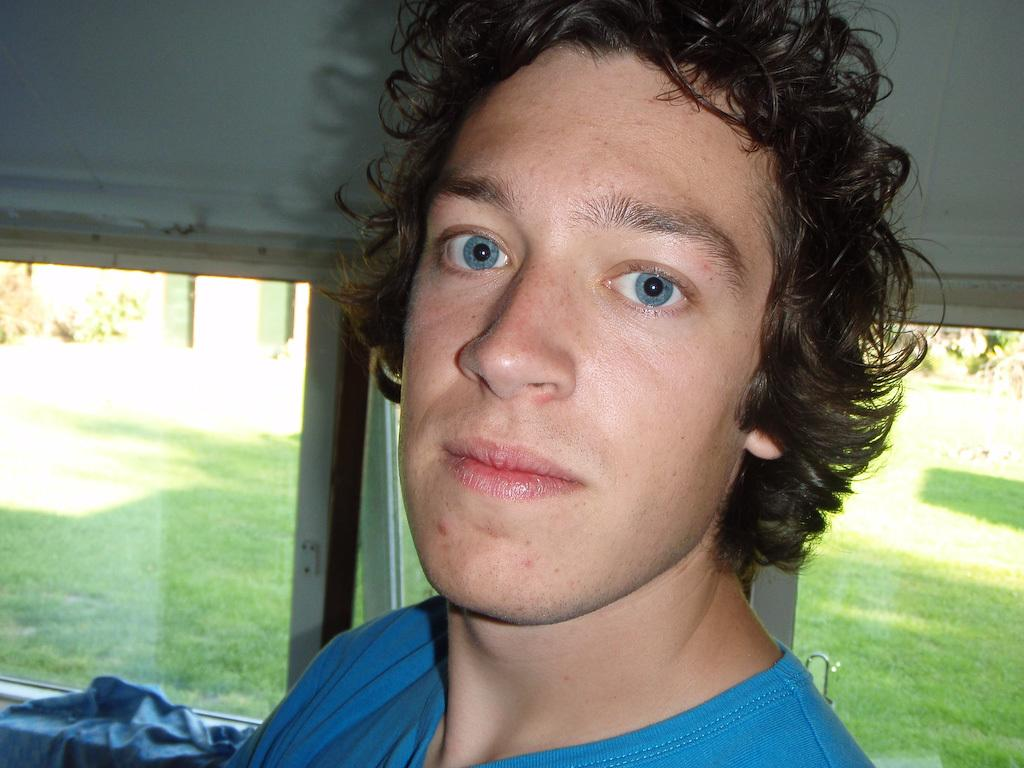What is the man in the image doing? The man is sitting on a chair in the image. What can be seen behind the man? There is a wall in the background of the image. What feature is present on the wall? There are windows in the wall. What is visible through the windows? A garden is visible through the windows. What type of feather can be seen on the man's hat in the image? There is no feather present on the man's hat in the image. What political party does the minister represent in the image? There is no minister present in the image. 